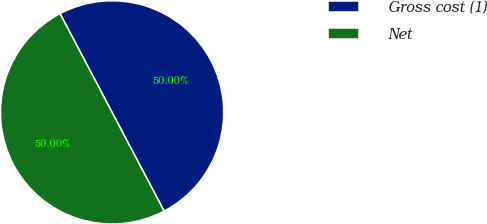Convert chart. <chart><loc_0><loc_0><loc_500><loc_500><pie_chart><fcel>Gross cost (1)<fcel>Net<nl><fcel>50.0%<fcel>50.0%<nl></chart> 